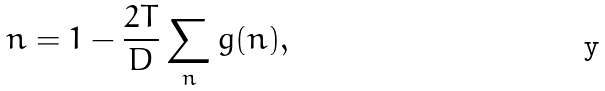<formula> <loc_0><loc_0><loc_500><loc_500>n = 1 - \frac { 2 T } { D } \sum _ { n } g ( n ) ,</formula> 